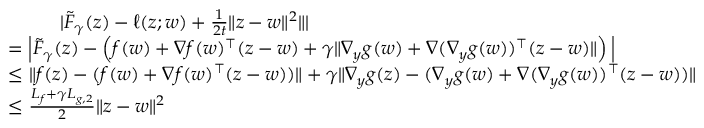Convert formula to latex. <formula><loc_0><loc_0><loc_500><loc_500>\begin{array} { r l } & { | \tilde { F } _ { \gamma } ( z ) - \ell ( z ; w ) + \frac { 1 } { 2 t } \| z - w \| ^ { 2 } \| | } \\ & { = \left | \tilde { F } _ { \gamma } ( z ) - \left ( f ( w ) + \nabla f ( w ) ^ { \top } ( z - w ) + \gamma \| \nabla _ { y } g ( w ) + \nabla ( \nabla _ { y } g ( w ) ) ^ { \top } ( z - w ) \| \right ) \right | } \\ & { \leq \| f ( z ) - ( f ( w ) + \nabla f ( w ) ^ { \top } ( z - w ) ) \| + \gamma \| \nabla _ { y } g ( z ) - ( \nabla _ { y } g ( w ) + \nabla ( \nabla _ { y } g ( w ) ) ^ { \top } ( z - w ) ) \| } \\ & { \leq \frac { L _ { f } + \gamma L _ { g , 2 } } { 2 } \| z - w \| ^ { 2 } } \end{array}</formula> 